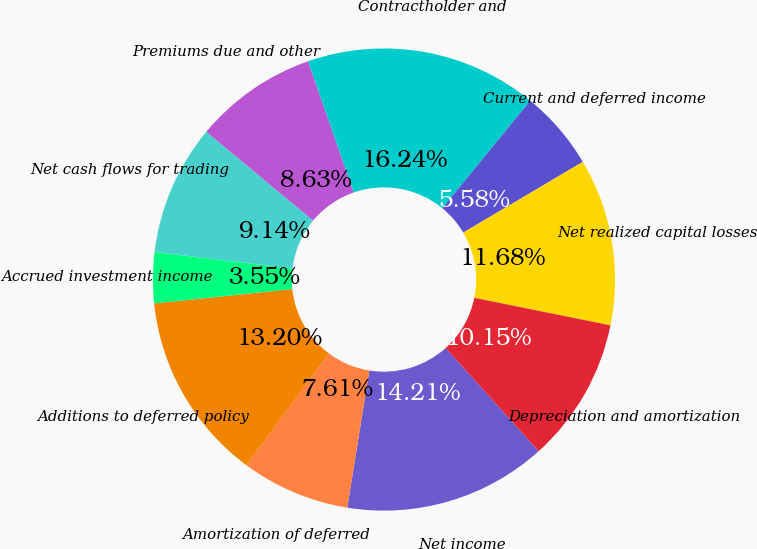Convert chart. <chart><loc_0><loc_0><loc_500><loc_500><pie_chart><fcel>Net income<fcel>Amortization of deferred<fcel>Additions to deferred policy<fcel>Accrued investment income<fcel>Net cash flows for trading<fcel>Premiums due and other<fcel>Contractholder and<fcel>Current and deferred income<fcel>Net realized capital losses<fcel>Depreciation and amortization<nl><fcel>14.21%<fcel>7.61%<fcel>13.2%<fcel>3.55%<fcel>9.14%<fcel>8.63%<fcel>16.24%<fcel>5.58%<fcel>11.68%<fcel>10.15%<nl></chart> 